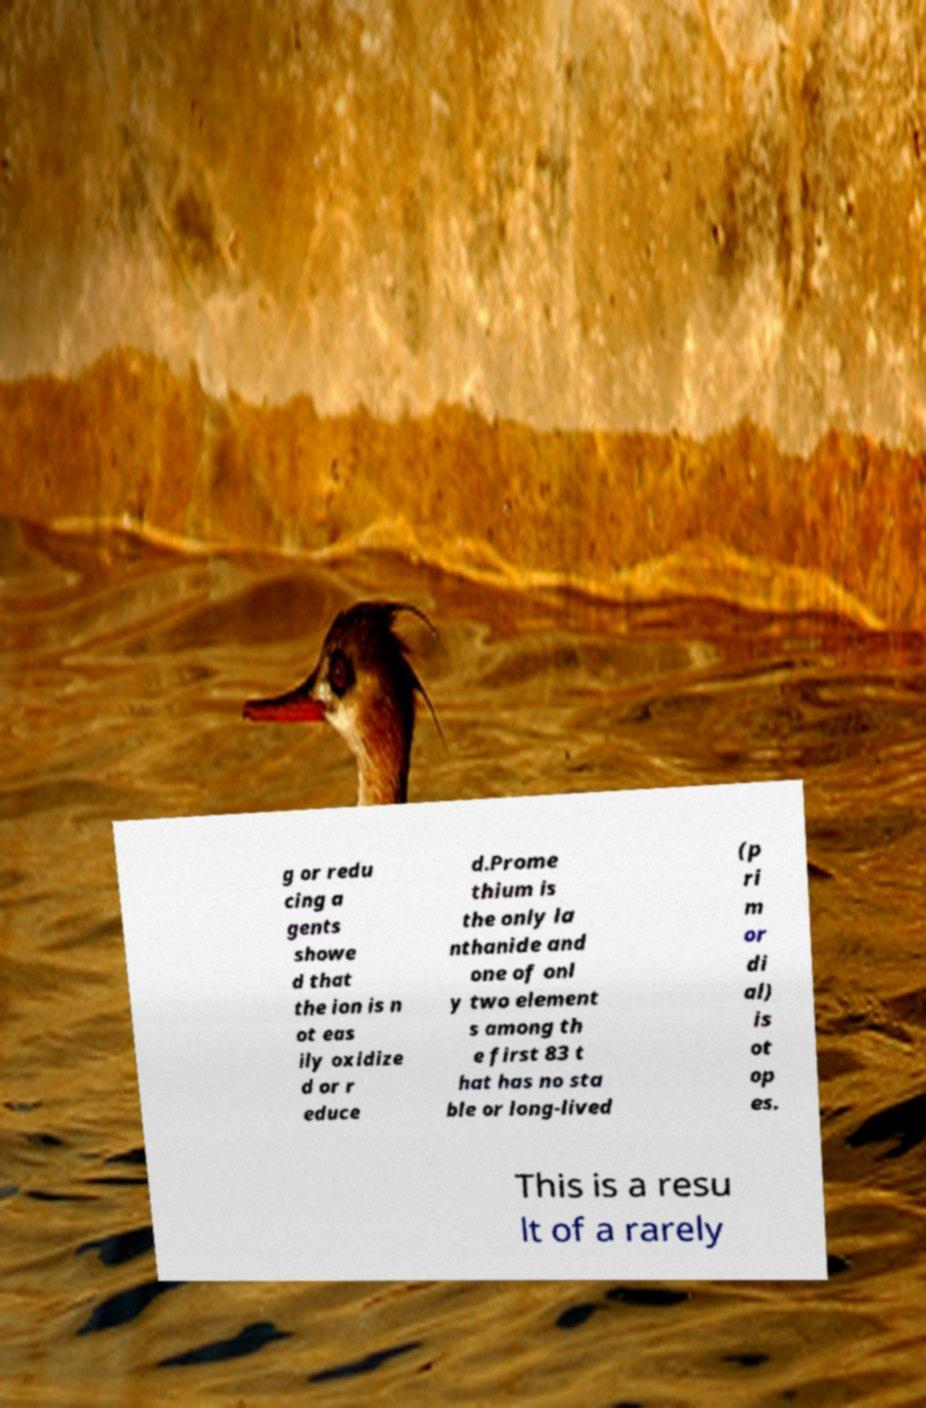Can you read and provide the text displayed in the image?This photo seems to have some interesting text. Can you extract and type it out for me? g or redu cing a gents showe d that the ion is n ot eas ily oxidize d or r educe d.Prome thium is the only la nthanide and one of onl y two element s among th e first 83 t hat has no sta ble or long-lived (p ri m or di al) is ot op es. This is a resu lt of a rarely 